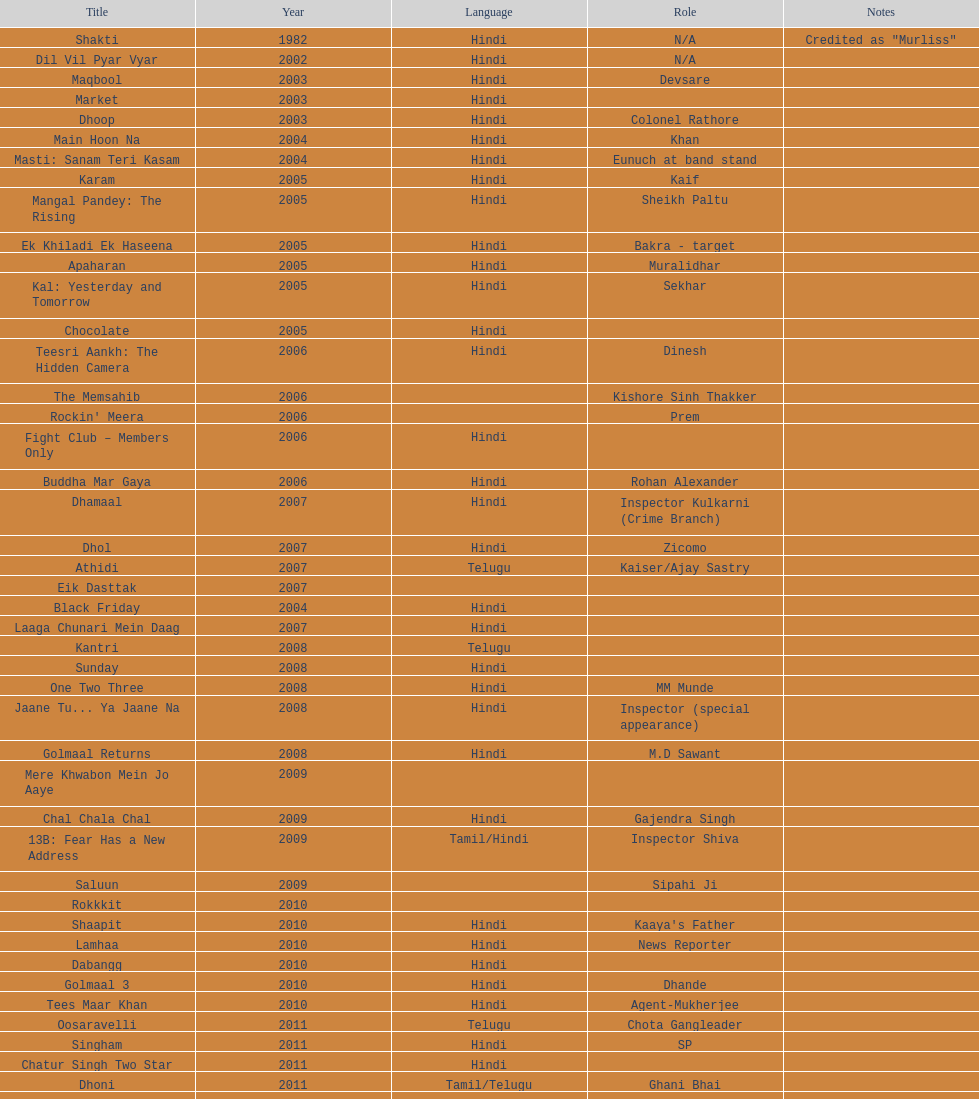What is the complete years on the chart? 13. 